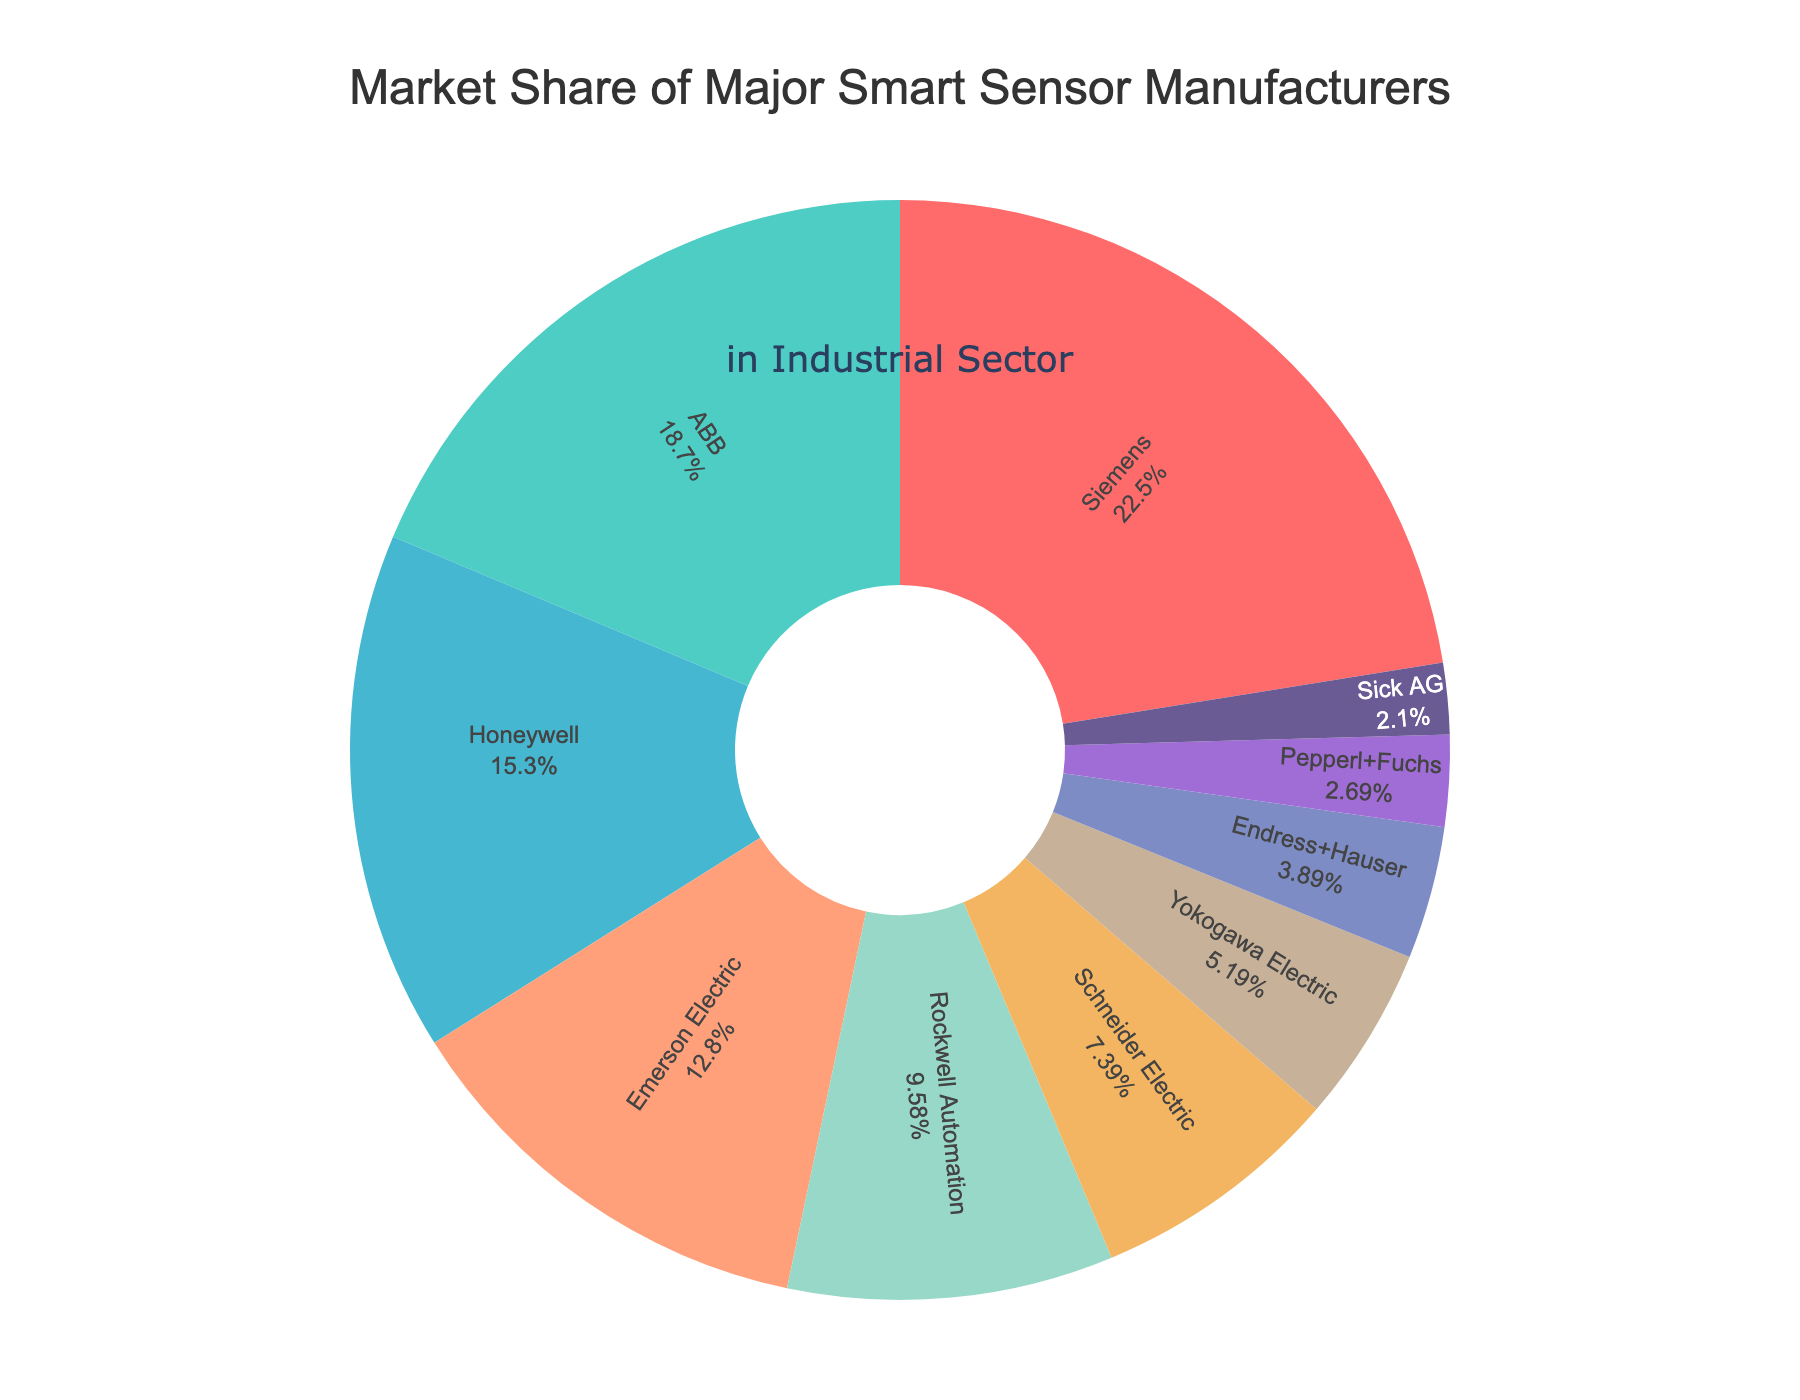Which manufacturer has the highest market share? By visually scanning the sectors of the pie chart, you can identify the largest sector, which represents Siemens.
Answer: Siemens How much more market share does Siemens have than Schneider Electric? Siemens has 22.5% market share and Schneider Electric has 7.4%. The difference is calculated as 22.5% - 7.4% = 15.1%.
Answer: 15.1% Which manufacturers collectively hold more market share: Rockwell Automation and Schneider Electric, or Emerson Electric and Honeywell? Rockwell Automation (9.6%) + Schneider Electric (7.4%) = 17%. Emerson Electric (12.8%) + Honeywell (15.3%) = 28.1%. Hence, Emerson Electric and Honeywell collectively hold more market share.
Answer: Emerson Electric and Honeywell What is the market share of the smallest two manufacturers combined? The smallest two manufacturers by market share are Sick AG (2.1%) and Pepperl+Fuchs (2.7%). Combined, their market share is 2.1% + 2.7% = 4.8%.
Answer: 4.8% Is ABB's market share greater than the combined market share of Endress+Hauser and Yokogawa Electric? ABB's market share is 18.7%. The combined market share of Endress+Hauser (3.9%) and Yokogawa Electric (5.2%) is 3.9% + 5.2% = 9.1%. Since 18.7% > 9.1%, ABB's market share is greater.
Answer: Yes What is the average market share of the top three manufacturers? The top three manufacturers in terms of market share are Siemens (22.5%), ABB (18.7%), and Honeywell (15.3%). The average is calculated as (22.5% + 18.7% + 15.3%) / 3 = 56.5% / 3 = 18.83%.
Answer: 18.83% If you combine the market share of the bottom four manufacturers, how much market share do they collectively hold? The bottom four manufacturers are Endress+Hauser (3.9%), Pepperl+Fuchs (2.7%), Sick AG (2.1%), and Yokogawa Electric (5.2%). Their combined market share is 3.9% + 2.7% + 2.1% + 5.2% = 13.9%.
Answer: 13.9% What percentage of the market is held by manufacturers other than the top three? The top three manufacturers hold 22.5% + 18.7% + 15.3% = 56.5%. Hence, the remaining manufacturers hold 100% - 56.5% = 43.5% of the market.
Answer: 43.5% Which manufacturer has a market share closest to 10%? By visual inspection, Rockwell Automation has a market share of 9.6%, which is closest to 10%.
Answer: Rockwell Automation 